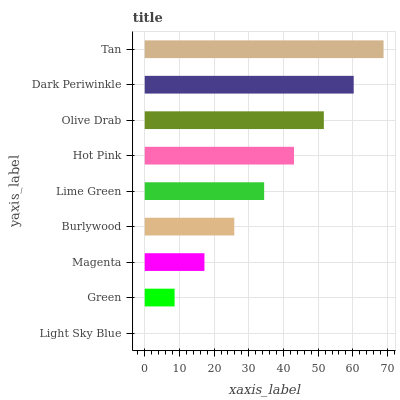Is Light Sky Blue the minimum?
Answer yes or no. Yes. Is Tan the maximum?
Answer yes or no. Yes. Is Green the minimum?
Answer yes or no. No. Is Green the maximum?
Answer yes or no. No. Is Green greater than Light Sky Blue?
Answer yes or no. Yes. Is Light Sky Blue less than Green?
Answer yes or no. Yes. Is Light Sky Blue greater than Green?
Answer yes or no. No. Is Green less than Light Sky Blue?
Answer yes or no. No. Is Lime Green the high median?
Answer yes or no. Yes. Is Lime Green the low median?
Answer yes or no. Yes. Is Burlywood the high median?
Answer yes or no. No. Is Magenta the low median?
Answer yes or no. No. 